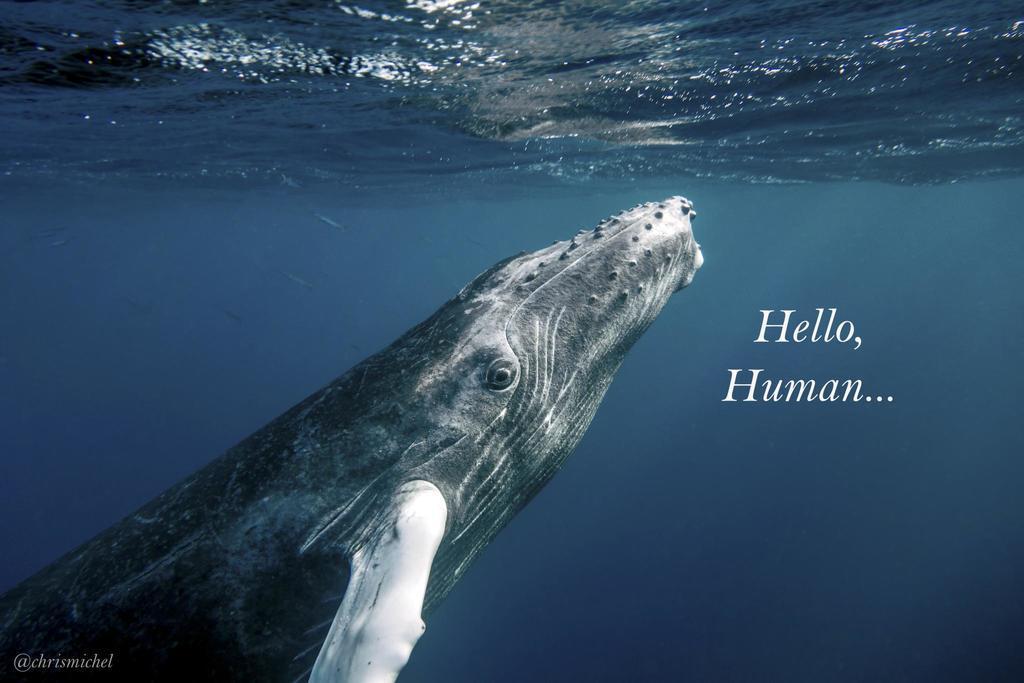Could you give a brief overview of what you see in this image? In this image we can see a poster. On this poster we can see picture of an animal, water, and text written on it. 